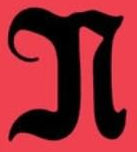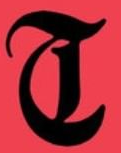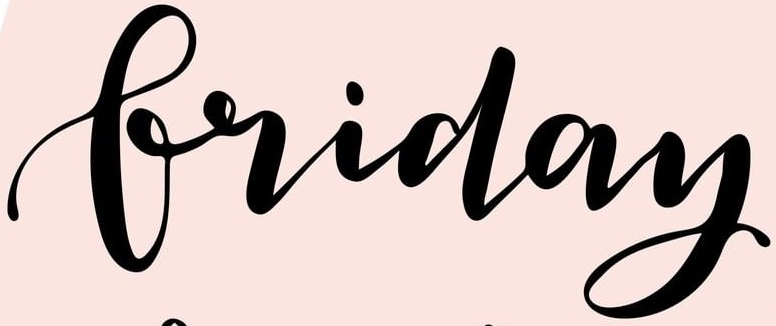Identify the words shown in these images in order, separated by a semicolon. N; T; Friday 